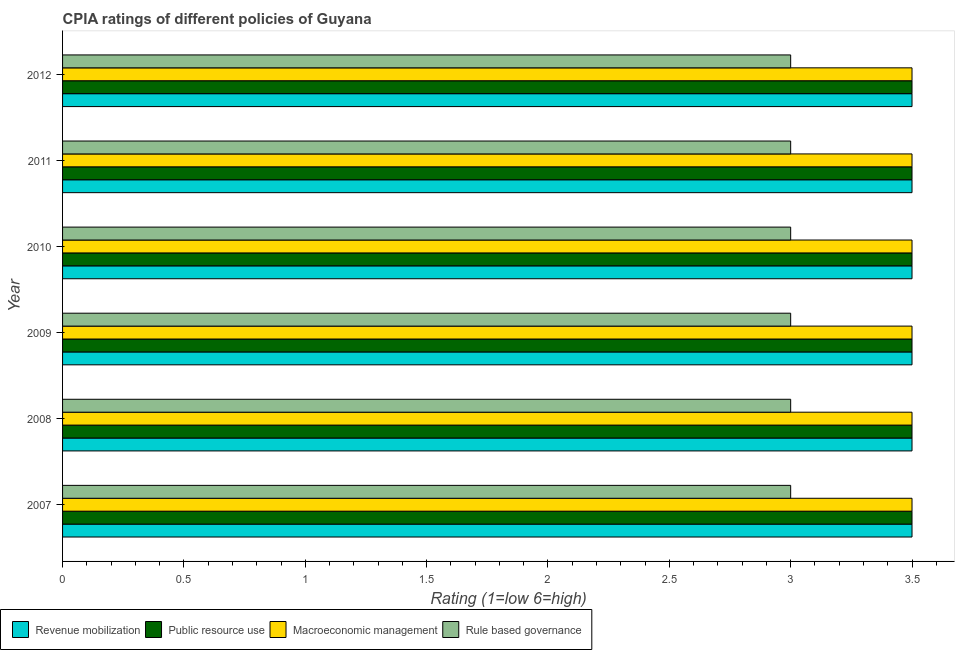Are the number of bars on each tick of the Y-axis equal?
Keep it short and to the point. Yes. What is the label of the 3rd group of bars from the top?
Your response must be concise. 2010. In how many cases, is the number of bars for a given year not equal to the number of legend labels?
Offer a terse response. 0. What is the cpia rating of public resource use in 2008?
Ensure brevity in your answer.  3.5. Across all years, what is the maximum cpia rating of rule based governance?
Offer a terse response. 3. In which year was the cpia rating of rule based governance maximum?
Give a very brief answer. 2007. In which year was the cpia rating of macroeconomic management minimum?
Ensure brevity in your answer.  2007. What is the difference between the cpia rating of revenue mobilization in 2009 and the cpia rating of public resource use in 2012?
Your answer should be very brief. 0. In how many years, is the cpia rating of public resource use greater than 0.30000000000000004 ?
Keep it short and to the point. 6. Is the cpia rating of rule based governance in 2008 less than that in 2012?
Your response must be concise. No. What is the difference between the highest and the second highest cpia rating of public resource use?
Give a very brief answer. 0. What is the difference between the highest and the lowest cpia rating of rule based governance?
Your answer should be compact. 0. Is the sum of the cpia rating of public resource use in 2007 and 2012 greater than the maximum cpia rating of rule based governance across all years?
Offer a terse response. Yes. What does the 3rd bar from the top in 2007 represents?
Ensure brevity in your answer.  Public resource use. What does the 1st bar from the bottom in 2008 represents?
Your response must be concise. Revenue mobilization. Is it the case that in every year, the sum of the cpia rating of revenue mobilization and cpia rating of public resource use is greater than the cpia rating of macroeconomic management?
Your answer should be very brief. Yes. How many bars are there?
Give a very brief answer. 24. How many years are there in the graph?
Offer a very short reply. 6. Does the graph contain any zero values?
Keep it short and to the point. No. Does the graph contain grids?
Give a very brief answer. No. How many legend labels are there?
Your answer should be very brief. 4. What is the title of the graph?
Give a very brief answer. CPIA ratings of different policies of Guyana. Does "Water" appear as one of the legend labels in the graph?
Provide a succinct answer. No. What is the label or title of the X-axis?
Your answer should be compact. Rating (1=low 6=high). What is the Rating (1=low 6=high) in Revenue mobilization in 2007?
Provide a succinct answer. 3.5. What is the Rating (1=low 6=high) of Rule based governance in 2007?
Your answer should be compact. 3. What is the Rating (1=low 6=high) in Public resource use in 2008?
Your answer should be very brief. 3.5. What is the Rating (1=low 6=high) of Public resource use in 2009?
Keep it short and to the point. 3.5. What is the Rating (1=low 6=high) in Revenue mobilization in 2010?
Your answer should be very brief. 3.5. What is the Rating (1=low 6=high) in Macroeconomic management in 2010?
Offer a terse response. 3.5. What is the Rating (1=low 6=high) of Rule based governance in 2010?
Ensure brevity in your answer.  3. What is the Rating (1=low 6=high) in Revenue mobilization in 2011?
Offer a very short reply. 3.5. What is the Rating (1=low 6=high) in Public resource use in 2011?
Your answer should be very brief. 3.5. What is the Rating (1=low 6=high) in Rule based governance in 2011?
Ensure brevity in your answer.  3. What is the Rating (1=low 6=high) of Revenue mobilization in 2012?
Make the answer very short. 3.5. What is the Rating (1=low 6=high) of Macroeconomic management in 2012?
Ensure brevity in your answer.  3.5. What is the Rating (1=low 6=high) in Rule based governance in 2012?
Provide a succinct answer. 3. Across all years, what is the maximum Rating (1=low 6=high) of Revenue mobilization?
Your response must be concise. 3.5. Across all years, what is the maximum Rating (1=low 6=high) in Public resource use?
Your answer should be compact. 3.5. Across all years, what is the maximum Rating (1=low 6=high) of Macroeconomic management?
Give a very brief answer. 3.5. Across all years, what is the minimum Rating (1=low 6=high) in Revenue mobilization?
Your response must be concise. 3.5. Across all years, what is the minimum Rating (1=low 6=high) in Macroeconomic management?
Ensure brevity in your answer.  3.5. What is the total Rating (1=low 6=high) of Revenue mobilization in the graph?
Your answer should be compact. 21. What is the difference between the Rating (1=low 6=high) in Revenue mobilization in 2007 and that in 2008?
Make the answer very short. 0. What is the difference between the Rating (1=low 6=high) of Rule based governance in 2007 and that in 2009?
Your answer should be very brief. 0. What is the difference between the Rating (1=low 6=high) in Macroeconomic management in 2007 and that in 2012?
Offer a very short reply. 0. What is the difference between the Rating (1=low 6=high) of Revenue mobilization in 2008 and that in 2009?
Provide a succinct answer. 0. What is the difference between the Rating (1=low 6=high) in Public resource use in 2008 and that in 2009?
Your answer should be compact. 0. What is the difference between the Rating (1=low 6=high) in Public resource use in 2008 and that in 2010?
Provide a succinct answer. 0. What is the difference between the Rating (1=low 6=high) in Macroeconomic management in 2008 and that in 2010?
Offer a terse response. 0. What is the difference between the Rating (1=low 6=high) of Revenue mobilization in 2008 and that in 2012?
Give a very brief answer. 0. What is the difference between the Rating (1=low 6=high) in Macroeconomic management in 2008 and that in 2012?
Ensure brevity in your answer.  0. What is the difference between the Rating (1=low 6=high) in Revenue mobilization in 2009 and that in 2010?
Provide a short and direct response. 0. What is the difference between the Rating (1=low 6=high) of Public resource use in 2009 and that in 2010?
Your answer should be compact. 0. What is the difference between the Rating (1=low 6=high) of Macroeconomic management in 2009 and that in 2010?
Keep it short and to the point. 0. What is the difference between the Rating (1=low 6=high) in Rule based governance in 2009 and that in 2010?
Your answer should be very brief. 0. What is the difference between the Rating (1=low 6=high) in Revenue mobilization in 2009 and that in 2011?
Provide a short and direct response. 0. What is the difference between the Rating (1=low 6=high) in Public resource use in 2009 and that in 2011?
Your response must be concise. 0. What is the difference between the Rating (1=low 6=high) of Macroeconomic management in 2009 and that in 2011?
Offer a terse response. 0. What is the difference between the Rating (1=low 6=high) in Rule based governance in 2009 and that in 2011?
Offer a terse response. 0. What is the difference between the Rating (1=low 6=high) of Revenue mobilization in 2009 and that in 2012?
Offer a terse response. 0. What is the difference between the Rating (1=low 6=high) in Public resource use in 2009 and that in 2012?
Give a very brief answer. 0. What is the difference between the Rating (1=low 6=high) in Macroeconomic management in 2009 and that in 2012?
Provide a short and direct response. 0. What is the difference between the Rating (1=low 6=high) in Revenue mobilization in 2010 and that in 2011?
Keep it short and to the point. 0. What is the difference between the Rating (1=low 6=high) in Public resource use in 2010 and that in 2011?
Offer a terse response. 0. What is the difference between the Rating (1=low 6=high) in Macroeconomic management in 2010 and that in 2011?
Your answer should be very brief. 0. What is the difference between the Rating (1=low 6=high) in Rule based governance in 2010 and that in 2011?
Provide a succinct answer. 0. What is the difference between the Rating (1=low 6=high) of Revenue mobilization in 2010 and that in 2012?
Offer a terse response. 0. What is the difference between the Rating (1=low 6=high) of Public resource use in 2010 and that in 2012?
Make the answer very short. 0. What is the difference between the Rating (1=low 6=high) of Macroeconomic management in 2010 and that in 2012?
Provide a succinct answer. 0. What is the difference between the Rating (1=low 6=high) of Rule based governance in 2010 and that in 2012?
Your answer should be compact. 0. What is the difference between the Rating (1=low 6=high) in Public resource use in 2011 and that in 2012?
Offer a terse response. 0. What is the difference between the Rating (1=low 6=high) in Rule based governance in 2011 and that in 2012?
Give a very brief answer. 0. What is the difference between the Rating (1=low 6=high) of Revenue mobilization in 2007 and the Rating (1=low 6=high) of Public resource use in 2008?
Keep it short and to the point. 0. What is the difference between the Rating (1=low 6=high) of Revenue mobilization in 2007 and the Rating (1=low 6=high) of Macroeconomic management in 2008?
Make the answer very short. 0. What is the difference between the Rating (1=low 6=high) in Macroeconomic management in 2007 and the Rating (1=low 6=high) in Rule based governance in 2008?
Provide a succinct answer. 0.5. What is the difference between the Rating (1=low 6=high) of Revenue mobilization in 2007 and the Rating (1=low 6=high) of Public resource use in 2009?
Offer a very short reply. 0. What is the difference between the Rating (1=low 6=high) of Public resource use in 2007 and the Rating (1=low 6=high) of Macroeconomic management in 2009?
Your response must be concise. 0. What is the difference between the Rating (1=low 6=high) in Macroeconomic management in 2007 and the Rating (1=low 6=high) in Rule based governance in 2009?
Your response must be concise. 0.5. What is the difference between the Rating (1=low 6=high) in Revenue mobilization in 2007 and the Rating (1=low 6=high) in Public resource use in 2010?
Offer a terse response. 0. What is the difference between the Rating (1=low 6=high) in Revenue mobilization in 2007 and the Rating (1=low 6=high) in Rule based governance in 2010?
Your answer should be very brief. 0.5. What is the difference between the Rating (1=low 6=high) in Public resource use in 2007 and the Rating (1=low 6=high) in Macroeconomic management in 2010?
Provide a succinct answer. 0. What is the difference between the Rating (1=low 6=high) of Public resource use in 2007 and the Rating (1=low 6=high) of Rule based governance in 2010?
Your response must be concise. 0.5. What is the difference between the Rating (1=low 6=high) of Revenue mobilization in 2007 and the Rating (1=low 6=high) of Macroeconomic management in 2011?
Ensure brevity in your answer.  0. What is the difference between the Rating (1=low 6=high) of Revenue mobilization in 2007 and the Rating (1=low 6=high) of Public resource use in 2012?
Your answer should be very brief. 0. What is the difference between the Rating (1=low 6=high) in Revenue mobilization in 2007 and the Rating (1=low 6=high) in Rule based governance in 2012?
Give a very brief answer. 0.5. What is the difference between the Rating (1=low 6=high) in Public resource use in 2007 and the Rating (1=low 6=high) in Rule based governance in 2012?
Your answer should be very brief. 0.5. What is the difference between the Rating (1=low 6=high) in Macroeconomic management in 2007 and the Rating (1=low 6=high) in Rule based governance in 2012?
Your response must be concise. 0.5. What is the difference between the Rating (1=low 6=high) of Revenue mobilization in 2008 and the Rating (1=low 6=high) of Rule based governance in 2009?
Give a very brief answer. 0.5. What is the difference between the Rating (1=low 6=high) of Public resource use in 2008 and the Rating (1=low 6=high) of Macroeconomic management in 2009?
Offer a terse response. 0. What is the difference between the Rating (1=low 6=high) of Public resource use in 2008 and the Rating (1=low 6=high) of Rule based governance in 2009?
Offer a very short reply. 0.5. What is the difference between the Rating (1=low 6=high) in Macroeconomic management in 2008 and the Rating (1=low 6=high) in Rule based governance in 2009?
Give a very brief answer. 0.5. What is the difference between the Rating (1=low 6=high) of Revenue mobilization in 2008 and the Rating (1=low 6=high) of Macroeconomic management in 2010?
Give a very brief answer. 0. What is the difference between the Rating (1=low 6=high) of Public resource use in 2008 and the Rating (1=low 6=high) of Macroeconomic management in 2010?
Ensure brevity in your answer.  0. What is the difference between the Rating (1=low 6=high) in Macroeconomic management in 2008 and the Rating (1=low 6=high) in Rule based governance in 2010?
Your answer should be very brief. 0.5. What is the difference between the Rating (1=low 6=high) of Revenue mobilization in 2008 and the Rating (1=low 6=high) of Public resource use in 2011?
Offer a very short reply. 0. What is the difference between the Rating (1=low 6=high) in Revenue mobilization in 2008 and the Rating (1=low 6=high) in Public resource use in 2012?
Give a very brief answer. 0. What is the difference between the Rating (1=low 6=high) in Revenue mobilization in 2008 and the Rating (1=low 6=high) in Macroeconomic management in 2012?
Offer a terse response. 0. What is the difference between the Rating (1=low 6=high) in Public resource use in 2008 and the Rating (1=low 6=high) in Macroeconomic management in 2012?
Ensure brevity in your answer.  0. What is the difference between the Rating (1=low 6=high) of Revenue mobilization in 2009 and the Rating (1=low 6=high) of Public resource use in 2010?
Offer a terse response. 0. What is the difference between the Rating (1=low 6=high) of Revenue mobilization in 2009 and the Rating (1=low 6=high) of Rule based governance in 2010?
Keep it short and to the point. 0.5. What is the difference between the Rating (1=low 6=high) in Public resource use in 2009 and the Rating (1=low 6=high) in Macroeconomic management in 2010?
Your answer should be compact. 0. What is the difference between the Rating (1=low 6=high) of Revenue mobilization in 2009 and the Rating (1=low 6=high) of Public resource use in 2011?
Make the answer very short. 0. What is the difference between the Rating (1=low 6=high) of Revenue mobilization in 2009 and the Rating (1=low 6=high) of Macroeconomic management in 2011?
Offer a very short reply. 0. What is the difference between the Rating (1=low 6=high) of Public resource use in 2009 and the Rating (1=low 6=high) of Macroeconomic management in 2011?
Your answer should be very brief. 0. What is the difference between the Rating (1=low 6=high) of Revenue mobilization in 2009 and the Rating (1=low 6=high) of Macroeconomic management in 2012?
Offer a very short reply. 0. What is the difference between the Rating (1=low 6=high) in Public resource use in 2009 and the Rating (1=low 6=high) in Rule based governance in 2012?
Provide a short and direct response. 0.5. What is the difference between the Rating (1=low 6=high) in Macroeconomic management in 2009 and the Rating (1=low 6=high) in Rule based governance in 2012?
Keep it short and to the point. 0.5. What is the difference between the Rating (1=low 6=high) of Revenue mobilization in 2010 and the Rating (1=low 6=high) of Rule based governance in 2011?
Your response must be concise. 0.5. What is the difference between the Rating (1=low 6=high) in Public resource use in 2010 and the Rating (1=low 6=high) in Macroeconomic management in 2011?
Offer a very short reply. 0. What is the difference between the Rating (1=low 6=high) of Public resource use in 2010 and the Rating (1=low 6=high) of Rule based governance in 2011?
Give a very brief answer. 0.5. What is the difference between the Rating (1=low 6=high) of Macroeconomic management in 2010 and the Rating (1=low 6=high) of Rule based governance in 2011?
Make the answer very short. 0.5. What is the difference between the Rating (1=low 6=high) of Revenue mobilization in 2010 and the Rating (1=low 6=high) of Public resource use in 2012?
Your response must be concise. 0. What is the difference between the Rating (1=low 6=high) in Public resource use in 2010 and the Rating (1=low 6=high) in Macroeconomic management in 2012?
Your answer should be compact. 0. What is the difference between the Rating (1=low 6=high) of Public resource use in 2010 and the Rating (1=low 6=high) of Rule based governance in 2012?
Your answer should be very brief. 0.5. What is the difference between the Rating (1=low 6=high) in Macroeconomic management in 2010 and the Rating (1=low 6=high) in Rule based governance in 2012?
Make the answer very short. 0.5. What is the difference between the Rating (1=low 6=high) in Revenue mobilization in 2011 and the Rating (1=low 6=high) in Public resource use in 2012?
Offer a terse response. 0. What is the difference between the Rating (1=low 6=high) in Revenue mobilization in 2011 and the Rating (1=low 6=high) in Macroeconomic management in 2012?
Provide a short and direct response. 0. What is the difference between the Rating (1=low 6=high) in Revenue mobilization in 2011 and the Rating (1=low 6=high) in Rule based governance in 2012?
Give a very brief answer. 0.5. What is the difference between the Rating (1=low 6=high) of Macroeconomic management in 2011 and the Rating (1=low 6=high) of Rule based governance in 2012?
Offer a terse response. 0.5. In the year 2007, what is the difference between the Rating (1=low 6=high) of Revenue mobilization and Rating (1=low 6=high) of Public resource use?
Offer a very short reply. 0. In the year 2007, what is the difference between the Rating (1=low 6=high) in Public resource use and Rating (1=low 6=high) in Rule based governance?
Offer a very short reply. 0.5. In the year 2007, what is the difference between the Rating (1=low 6=high) of Macroeconomic management and Rating (1=low 6=high) of Rule based governance?
Your answer should be compact. 0.5. In the year 2008, what is the difference between the Rating (1=low 6=high) in Revenue mobilization and Rating (1=low 6=high) in Macroeconomic management?
Offer a terse response. 0. In the year 2008, what is the difference between the Rating (1=low 6=high) in Public resource use and Rating (1=low 6=high) in Rule based governance?
Provide a succinct answer. 0.5. In the year 2009, what is the difference between the Rating (1=low 6=high) of Revenue mobilization and Rating (1=low 6=high) of Public resource use?
Keep it short and to the point. 0. In the year 2009, what is the difference between the Rating (1=low 6=high) of Revenue mobilization and Rating (1=low 6=high) of Macroeconomic management?
Keep it short and to the point. 0. In the year 2009, what is the difference between the Rating (1=low 6=high) of Public resource use and Rating (1=low 6=high) of Rule based governance?
Your answer should be very brief. 0.5. In the year 2009, what is the difference between the Rating (1=low 6=high) of Macroeconomic management and Rating (1=low 6=high) of Rule based governance?
Ensure brevity in your answer.  0.5. In the year 2010, what is the difference between the Rating (1=low 6=high) in Revenue mobilization and Rating (1=low 6=high) in Public resource use?
Provide a succinct answer. 0. In the year 2010, what is the difference between the Rating (1=low 6=high) in Public resource use and Rating (1=low 6=high) in Macroeconomic management?
Offer a very short reply. 0. In the year 2010, what is the difference between the Rating (1=low 6=high) of Public resource use and Rating (1=low 6=high) of Rule based governance?
Provide a short and direct response. 0.5. In the year 2010, what is the difference between the Rating (1=low 6=high) in Macroeconomic management and Rating (1=low 6=high) in Rule based governance?
Give a very brief answer. 0.5. In the year 2011, what is the difference between the Rating (1=low 6=high) of Revenue mobilization and Rating (1=low 6=high) of Macroeconomic management?
Your answer should be very brief. 0. In the year 2011, what is the difference between the Rating (1=low 6=high) in Public resource use and Rating (1=low 6=high) in Rule based governance?
Your answer should be very brief. 0.5. In the year 2011, what is the difference between the Rating (1=low 6=high) of Macroeconomic management and Rating (1=low 6=high) of Rule based governance?
Give a very brief answer. 0.5. In the year 2012, what is the difference between the Rating (1=low 6=high) of Revenue mobilization and Rating (1=low 6=high) of Macroeconomic management?
Offer a terse response. 0. In the year 2012, what is the difference between the Rating (1=low 6=high) in Revenue mobilization and Rating (1=low 6=high) in Rule based governance?
Ensure brevity in your answer.  0.5. In the year 2012, what is the difference between the Rating (1=low 6=high) in Public resource use and Rating (1=low 6=high) in Macroeconomic management?
Offer a terse response. 0. In the year 2012, what is the difference between the Rating (1=low 6=high) of Macroeconomic management and Rating (1=low 6=high) of Rule based governance?
Offer a very short reply. 0.5. What is the ratio of the Rating (1=low 6=high) in Revenue mobilization in 2007 to that in 2008?
Provide a succinct answer. 1. What is the ratio of the Rating (1=low 6=high) of Public resource use in 2007 to that in 2008?
Provide a short and direct response. 1. What is the ratio of the Rating (1=low 6=high) in Rule based governance in 2007 to that in 2008?
Your answer should be very brief. 1. What is the ratio of the Rating (1=low 6=high) of Public resource use in 2007 to that in 2009?
Keep it short and to the point. 1. What is the ratio of the Rating (1=low 6=high) of Macroeconomic management in 2007 to that in 2009?
Keep it short and to the point. 1. What is the ratio of the Rating (1=low 6=high) of Public resource use in 2007 to that in 2010?
Give a very brief answer. 1. What is the ratio of the Rating (1=low 6=high) of Revenue mobilization in 2007 to that in 2011?
Your response must be concise. 1. What is the ratio of the Rating (1=low 6=high) of Macroeconomic management in 2007 to that in 2011?
Give a very brief answer. 1. What is the ratio of the Rating (1=low 6=high) of Revenue mobilization in 2007 to that in 2012?
Give a very brief answer. 1. What is the ratio of the Rating (1=low 6=high) in Macroeconomic management in 2007 to that in 2012?
Provide a short and direct response. 1. What is the ratio of the Rating (1=low 6=high) in Rule based governance in 2007 to that in 2012?
Provide a succinct answer. 1. What is the ratio of the Rating (1=low 6=high) of Public resource use in 2008 to that in 2009?
Your answer should be very brief. 1. What is the ratio of the Rating (1=low 6=high) of Macroeconomic management in 2008 to that in 2009?
Keep it short and to the point. 1. What is the ratio of the Rating (1=low 6=high) of Public resource use in 2008 to that in 2010?
Provide a succinct answer. 1. What is the ratio of the Rating (1=low 6=high) in Macroeconomic management in 2008 to that in 2010?
Provide a succinct answer. 1. What is the ratio of the Rating (1=low 6=high) of Public resource use in 2008 to that in 2011?
Offer a very short reply. 1. What is the ratio of the Rating (1=low 6=high) of Macroeconomic management in 2008 to that in 2011?
Give a very brief answer. 1. What is the ratio of the Rating (1=low 6=high) of Rule based governance in 2008 to that in 2012?
Offer a very short reply. 1. What is the ratio of the Rating (1=low 6=high) in Macroeconomic management in 2009 to that in 2010?
Your answer should be compact. 1. What is the ratio of the Rating (1=low 6=high) of Rule based governance in 2009 to that in 2010?
Ensure brevity in your answer.  1. What is the ratio of the Rating (1=low 6=high) of Public resource use in 2009 to that in 2011?
Make the answer very short. 1. What is the ratio of the Rating (1=low 6=high) in Macroeconomic management in 2009 to that in 2011?
Ensure brevity in your answer.  1. What is the ratio of the Rating (1=low 6=high) in Rule based governance in 2009 to that in 2011?
Offer a very short reply. 1. What is the ratio of the Rating (1=low 6=high) in Revenue mobilization in 2009 to that in 2012?
Your answer should be compact. 1. What is the ratio of the Rating (1=low 6=high) in Public resource use in 2009 to that in 2012?
Offer a terse response. 1. What is the ratio of the Rating (1=low 6=high) in Rule based governance in 2009 to that in 2012?
Give a very brief answer. 1. What is the ratio of the Rating (1=low 6=high) of Revenue mobilization in 2010 to that in 2011?
Make the answer very short. 1. What is the ratio of the Rating (1=low 6=high) of Public resource use in 2010 to that in 2011?
Your answer should be compact. 1. What is the ratio of the Rating (1=low 6=high) of Rule based governance in 2010 to that in 2011?
Offer a terse response. 1. What is the ratio of the Rating (1=low 6=high) in Revenue mobilization in 2010 to that in 2012?
Offer a terse response. 1. What is the ratio of the Rating (1=low 6=high) in Public resource use in 2010 to that in 2012?
Ensure brevity in your answer.  1. What is the ratio of the Rating (1=low 6=high) of Revenue mobilization in 2011 to that in 2012?
Offer a terse response. 1. What is the ratio of the Rating (1=low 6=high) of Macroeconomic management in 2011 to that in 2012?
Ensure brevity in your answer.  1. What is the difference between the highest and the second highest Rating (1=low 6=high) of Revenue mobilization?
Offer a very short reply. 0. What is the difference between the highest and the second highest Rating (1=low 6=high) of Macroeconomic management?
Offer a very short reply. 0. What is the difference between the highest and the second highest Rating (1=low 6=high) of Rule based governance?
Make the answer very short. 0. What is the difference between the highest and the lowest Rating (1=low 6=high) in Public resource use?
Provide a short and direct response. 0. 